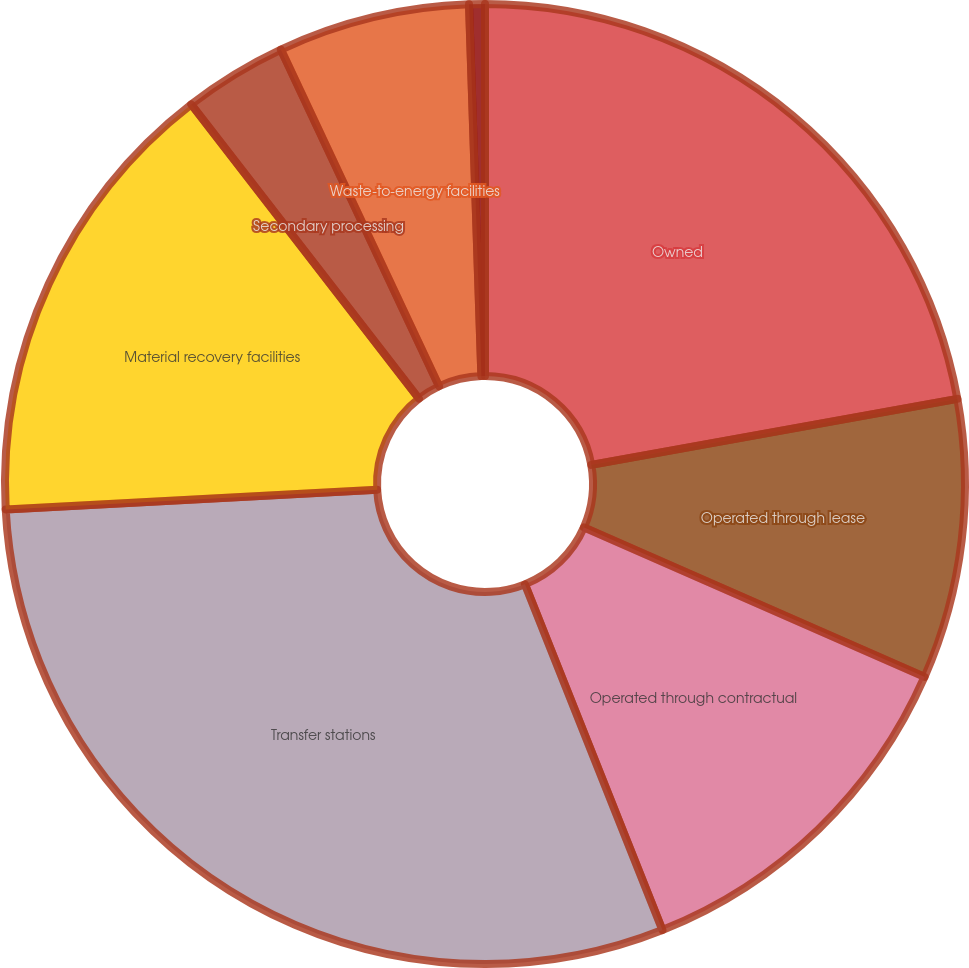<chart> <loc_0><loc_0><loc_500><loc_500><pie_chart><fcel>Owned<fcel>Operated through lease<fcel>Operated through contractual<fcel>Transfer stations<fcel>Material recovery facilities<fcel>Secondary processing<fcel>Waste-to-energy facilities<fcel>Independent power production<nl><fcel>22.16%<fcel>9.42%<fcel>12.39%<fcel>30.18%<fcel>15.36%<fcel>3.49%<fcel>6.46%<fcel>0.53%<nl></chart> 